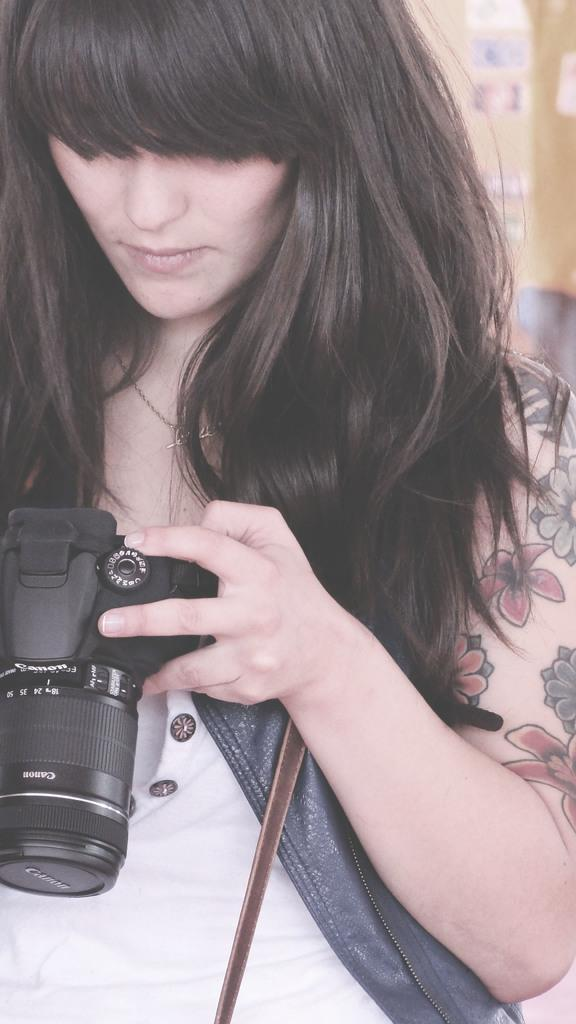What is the woman holding in the image? The woman is holding a camera. Can you describe the woman's clothing in the image? The woman is wearing a white dress and a blue jacket. What can be seen on the woman's left hand? There is a tattoo on her left hand. How is the woman's hair styled in the image? The woman has her hair left down. What type of straw is the woman using to fly the planes in the image? There are no planes or straws present in the image; it features a woman holding a camera and wearing a white dress and blue jacket. 